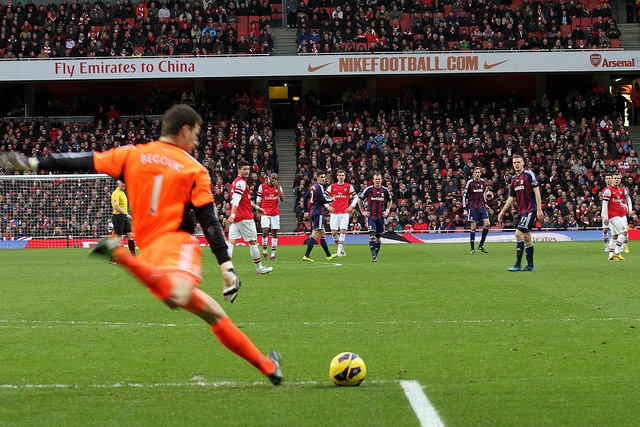Describe the objects in this image and their specific colors. I can see people in teal, black, gray, maroon, and brown tones, people in teal, red, black, and orange tones, people in teal, black, maroon, gray, and tan tones, people in teal, lightgray, darkgray, and brown tones, and people in teal, lightgray, red, darkgray, and brown tones in this image. 